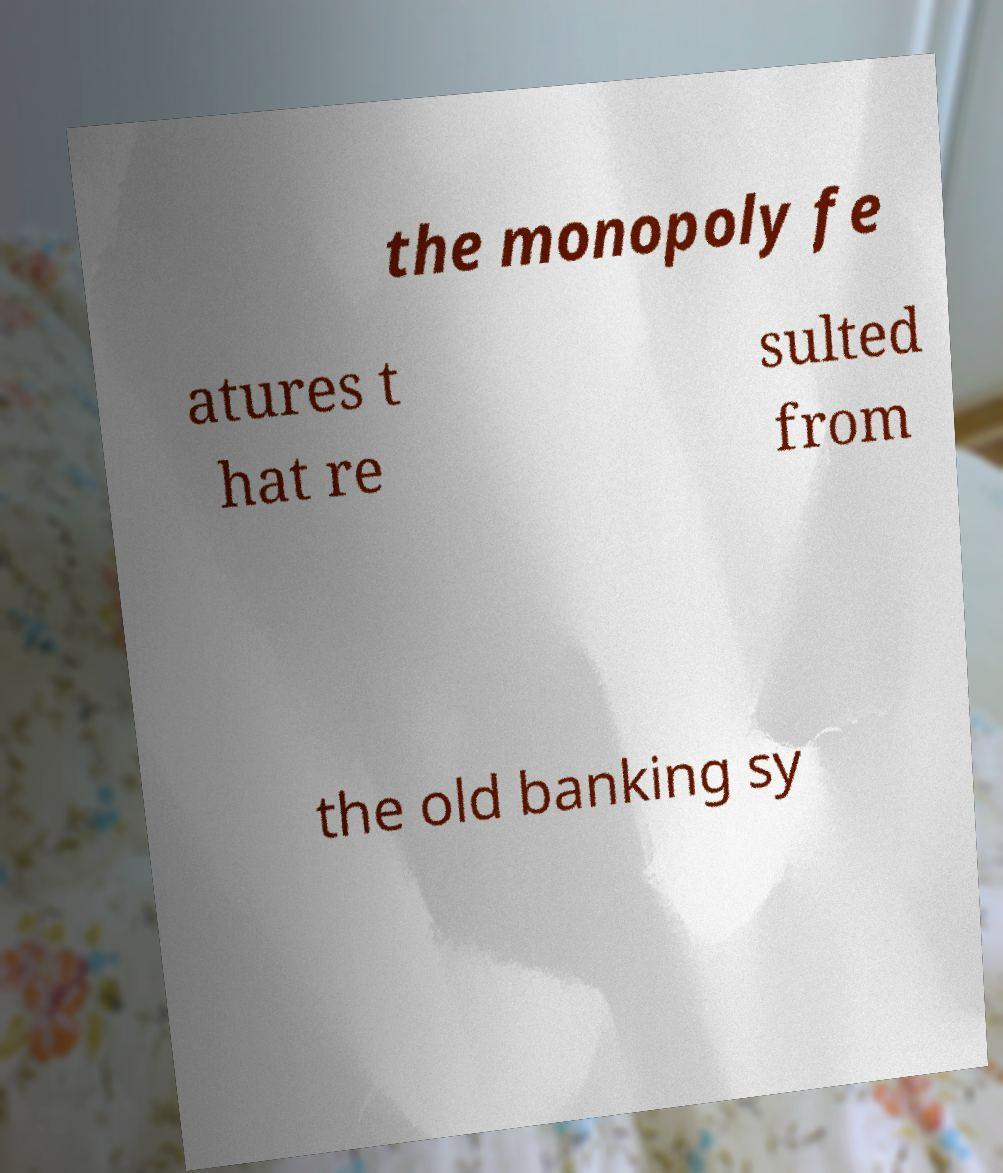Could you extract and type out the text from this image? the monopoly fe atures t hat re sulted from the old banking sy 